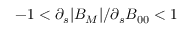<formula> <loc_0><loc_0><loc_500><loc_500>- 1 < \partial _ { s } | B _ { M } | / \partial _ { s } B _ { 0 0 } < 1</formula> 